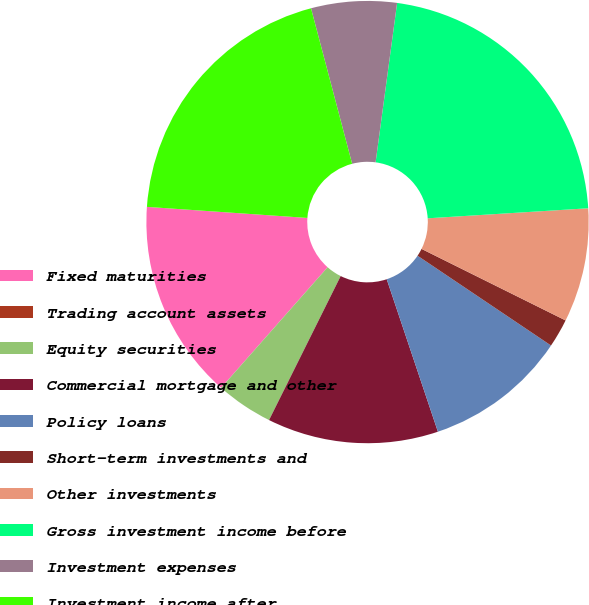<chart> <loc_0><loc_0><loc_500><loc_500><pie_chart><fcel>Fixed maturities<fcel>Trading account assets<fcel>Equity securities<fcel>Commercial mortgage and other<fcel>Policy loans<fcel>Short-term investments and<fcel>Other investments<fcel>Gross investment income before<fcel>Investment expenses<fcel>Investment income after<nl><fcel>14.58%<fcel>0.0%<fcel>4.17%<fcel>12.5%<fcel>10.42%<fcel>2.09%<fcel>8.33%<fcel>21.87%<fcel>6.25%<fcel>19.79%<nl></chart> 